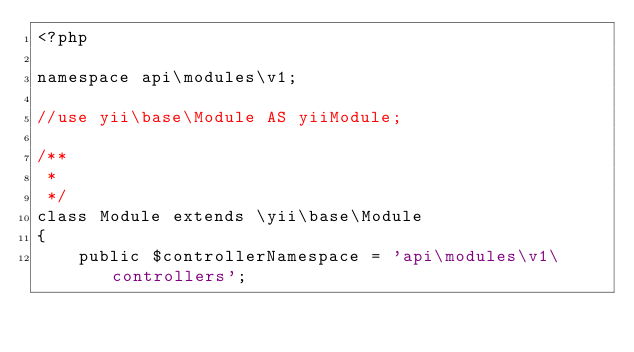<code> <loc_0><loc_0><loc_500><loc_500><_PHP_><?php

namespace api\modules\v1;

//use yii\base\Module AS yiiModule;

/**
 *
 */
class Module extends \yii\base\Module
{
    public $controllerNamespace = 'api\modules\v1\controllers';
</code> 